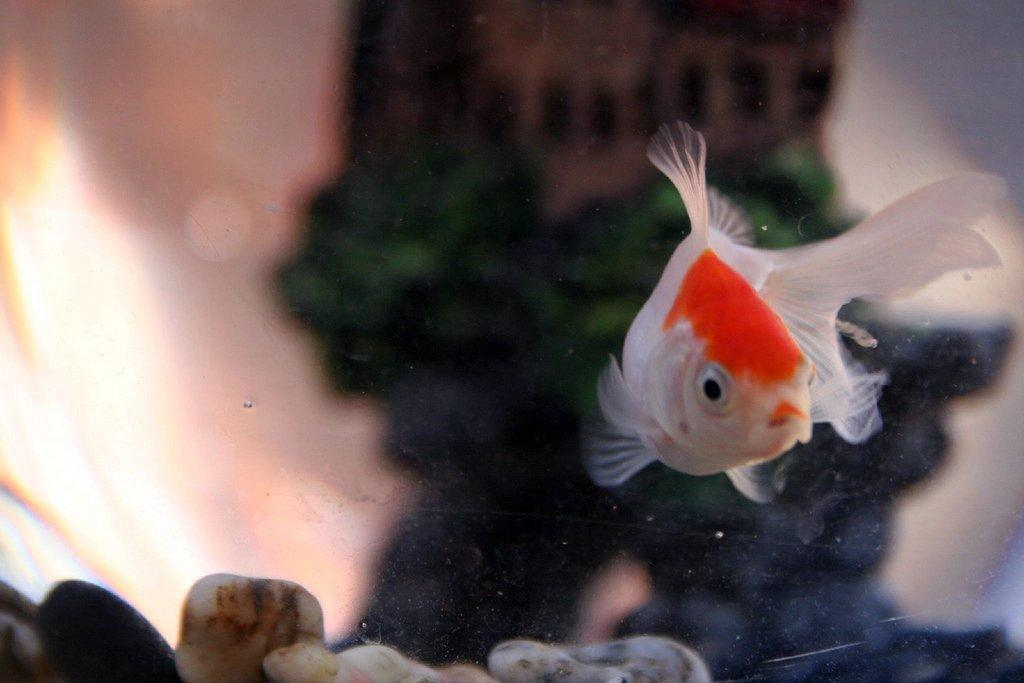What type of animal is in the image? There is a fish in the image. What else can be seen in the image besides the fish? There are stones and objects in the water in the image. Where is the rabbit being held in the image? There is no rabbit present in the image. What type of material is the wax used for in the image? There is no wax present in the image. 